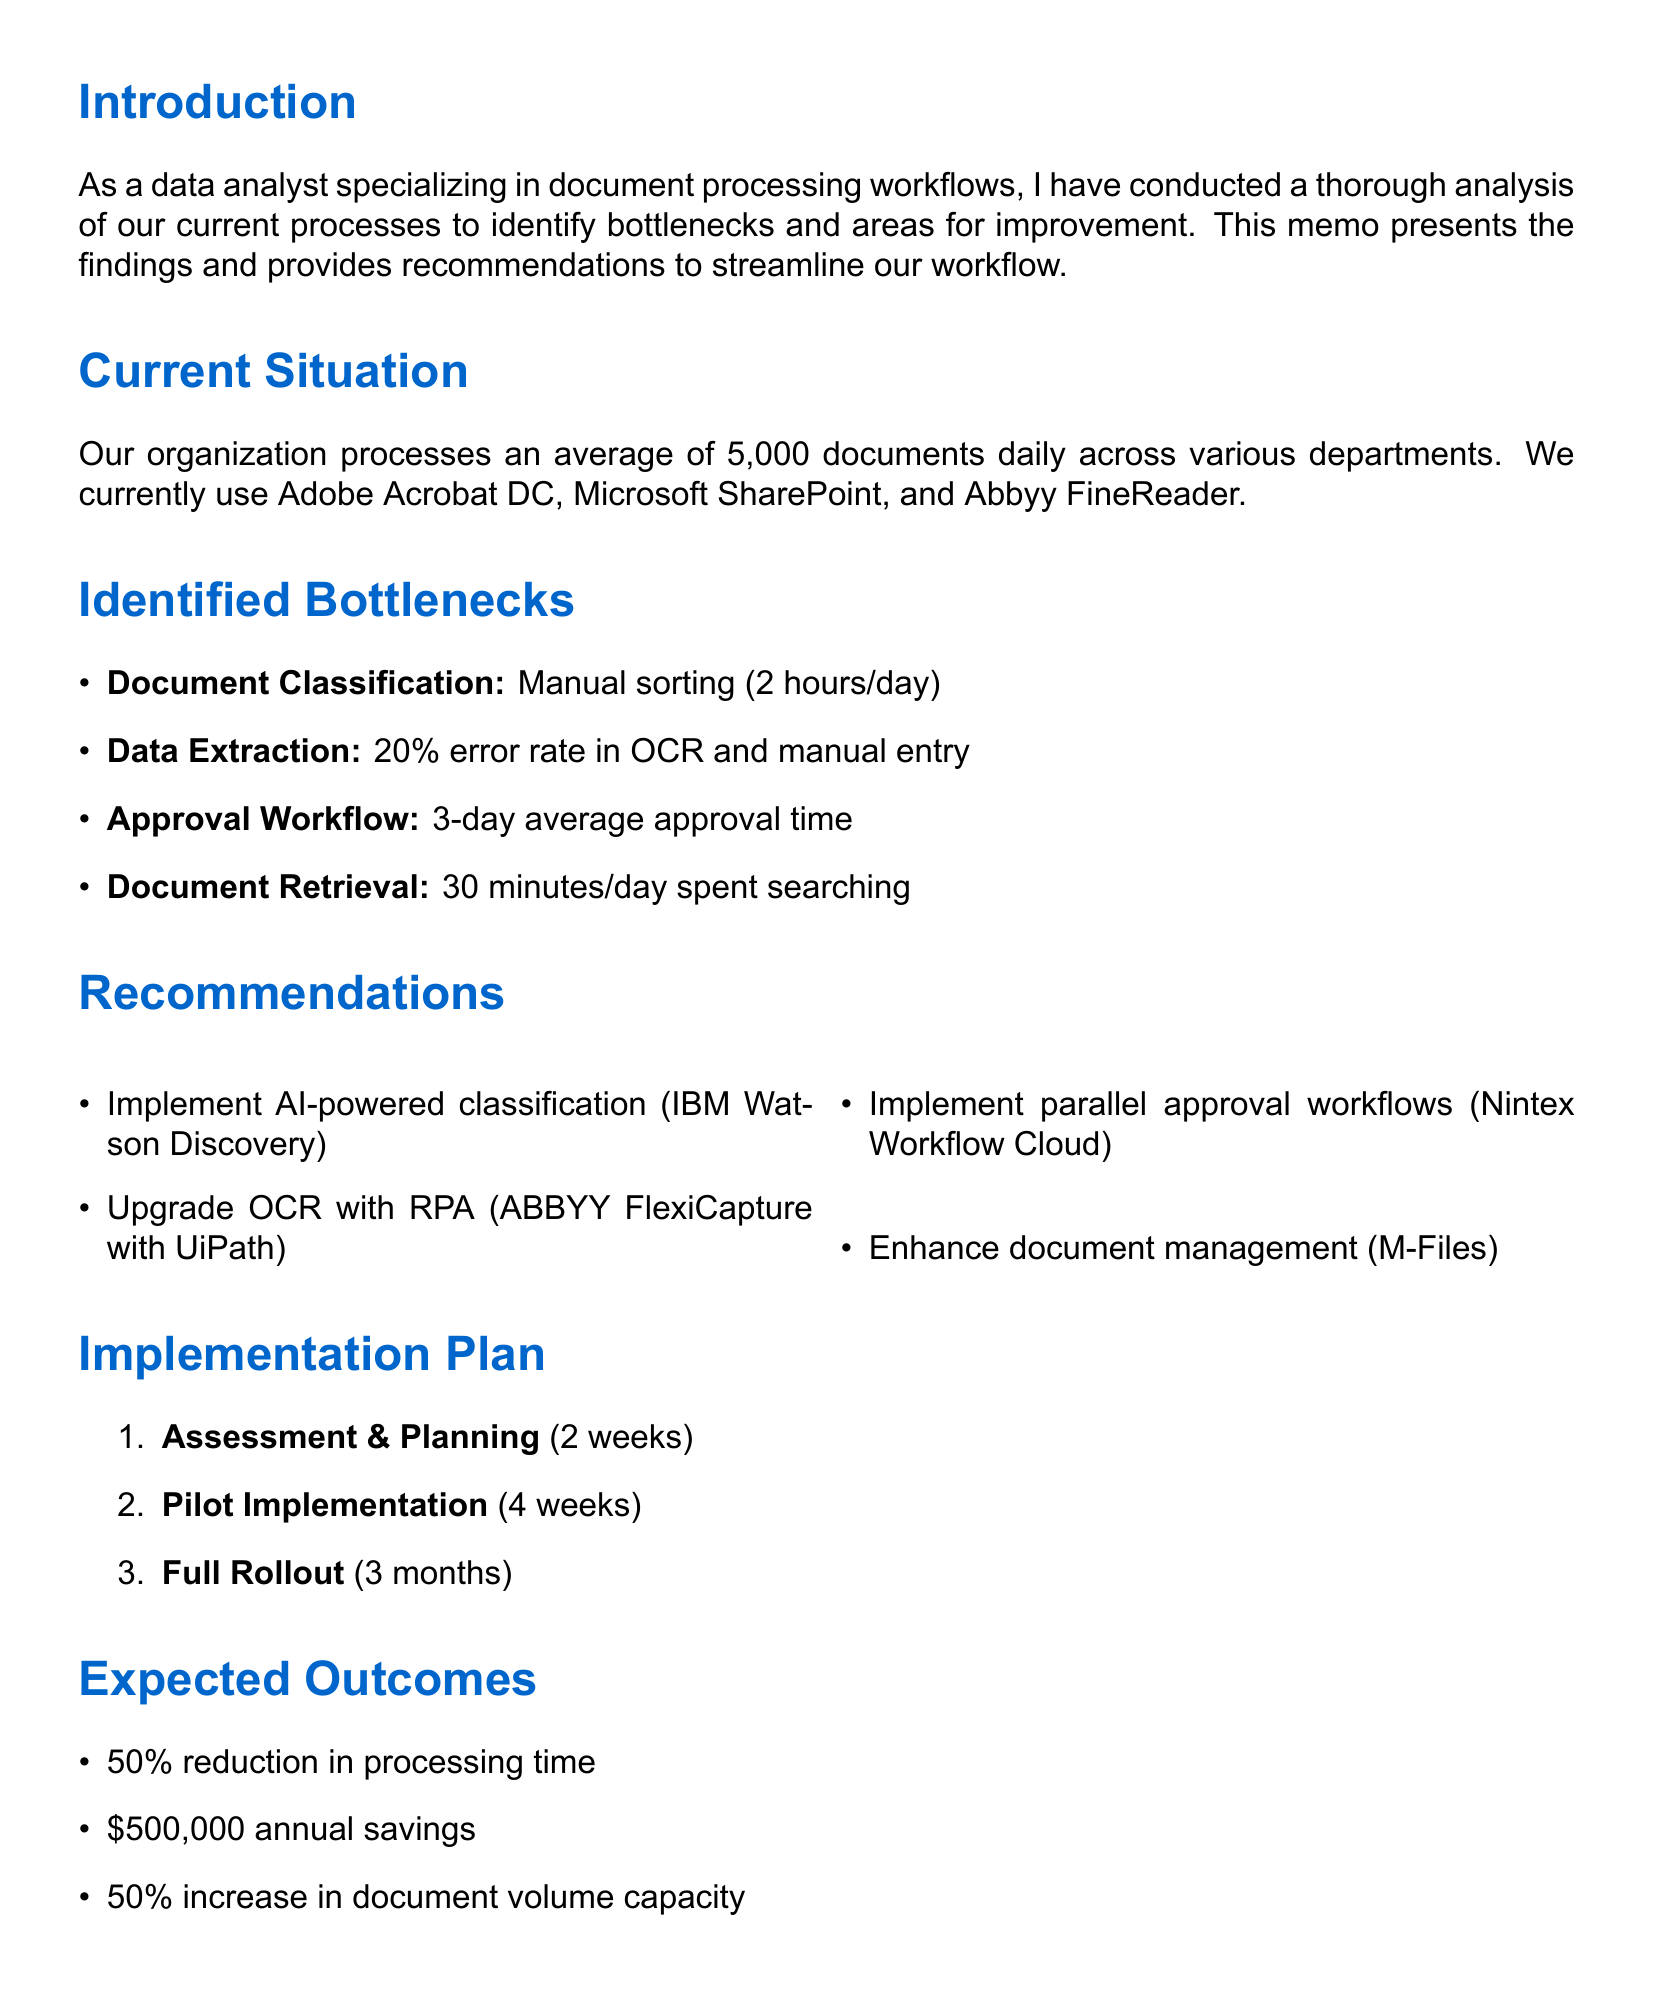What is the average number of documents processed daily? The memo states that the organization processes an average of 5,000 documents daily.
Answer: 5,000 What tool is recommended for AI-powered document classification? The recommendation for AI-powered document classification is IBM Watson Discovery.
Answer: IBM Watson Discovery What is the estimated annual savings in labor costs and error reduction? The document states that the estimated annual savings is $500,000.
Answer: $500,000 How long is the proposed pilot implementation phase? The memo indicates that the pilot implementation phase will last for 4 weeks.
Answer: 4 weeks What problem is associated with the approval workflow? The document mentions that there are frequent delays due to unavailable approvers.
Answer: Delays due to unavailable approvers What is the expected percentage reduction in overall document processing time? The memo indicates an expected 50% reduction in overall document processing time.
Answer: 50% Which tool is suggested for enhancing document management system capabilities? The suggested tool for enhancing the document management system is M-Files.
Answer: M-Files How many departments currently utilize the document processing workflow? The overview states that various departments including HR, Finance, and Legal are involved, indicating multiple departments.
Answer: Various departments What is the duration of the full rollout phase? The full rollout phase is expected to take 3 months, as mentioned in the implementation plan.
Answer: 3 months 